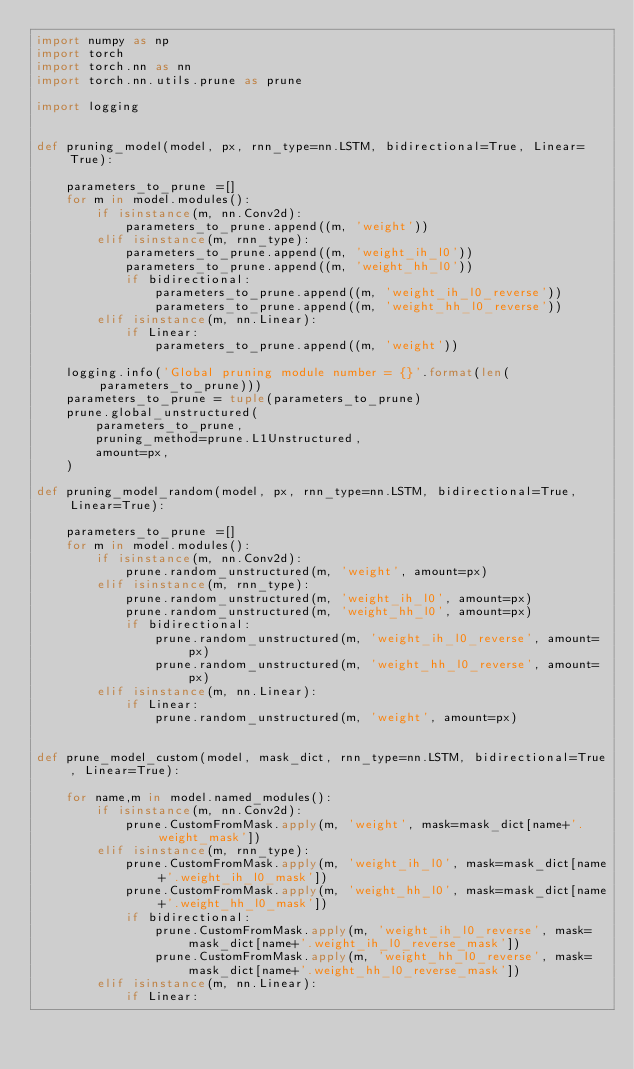Convert code to text. <code><loc_0><loc_0><loc_500><loc_500><_Python_>import numpy as np
import torch
import torch.nn as nn
import torch.nn.utils.prune as prune

import logging


def pruning_model(model, px, rnn_type=nn.LSTM, bidirectional=True, Linear=True):

    parameters_to_prune =[]
    for m in model.modules():
        if isinstance(m, nn.Conv2d):
            parameters_to_prune.append((m, 'weight'))
        elif isinstance(m, rnn_type):
            parameters_to_prune.append((m, 'weight_ih_l0'))
            parameters_to_prune.append((m, 'weight_hh_l0'))
            if bidirectional:
                parameters_to_prune.append((m, 'weight_ih_l0_reverse'))
                parameters_to_prune.append((m, 'weight_hh_l0_reverse'))
        elif isinstance(m, nn.Linear):
            if Linear:
                parameters_to_prune.append((m, 'weight'))

    logging.info('Global pruning module number = {}'.format(len(parameters_to_prune)))
    parameters_to_prune = tuple(parameters_to_prune)
    prune.global_unstructured(
        parameters_to_prune,
        pruning_method=prune.L1Unstructured,
        amount=px,
    )

def pruning_model_random(model, px, rnn_type=nn.LSTM, bidirectional=True, Linear=True):

    parameters_to_prune =[]
    for m in model.modules():
        if isinstance(m, nn.Conv2d):
            prune.random_unstructured(m, 'weight', amount=px)
        elif isinstance(m, rnn_type):
            prune.random_unstructured(m, 'weight_ih_l0', amount=px)
            prune.random_unstructured(m, 'weight_hh_l0', amount=px)
            if bidirectional:
                prune.random_unstructured(m, 'weight_ih_l0_reverse', amount=px)
                prune.random_unstructured(m, 'weight_hh_l0_reverse', amount=px)
        elif isinstance(m, nn.Linear):
            if Linear:
                prune.random_unstructured(m, 'weight', amount=px)


def prune_model_custom(model, mask_dict, rnn_type=nn.LSTM, bidirectional=True, Linear=True):

    for name,m in model.named_modules():
        if isinstance(m, nn.Conv2d):
            prune.CustomFromMask.apply(m, 'weight', mask=mask_dict[name+'.weight_mask'])
        elif isinstance(m, rnn_type):
            prune.CustomFromMask.apply(m, 'weight_ih_l0', mask=mask_dict[name+'.weight_ih_l0_mask'])
            prune.CustomFromMask.apply(m, 'weight_hh_l0', mask=mask_dict[name+'.weight_hh_l0_mask'])
            if bidirectional:
                prune.CustomFromMask.apply(m, 'weight_ih_l0_reverse', mask=mask_dict[name+'.weight_ih_l0_reverse_mask'])
                prune.CustomFromMask.apply(m, 'weight_hh_l0_reverse', mask=mask_dict[name+'.weight_hh_l0_reverse_mask'])
        elif isinstance(m, nn.Linear):
            if Linear:</code> 